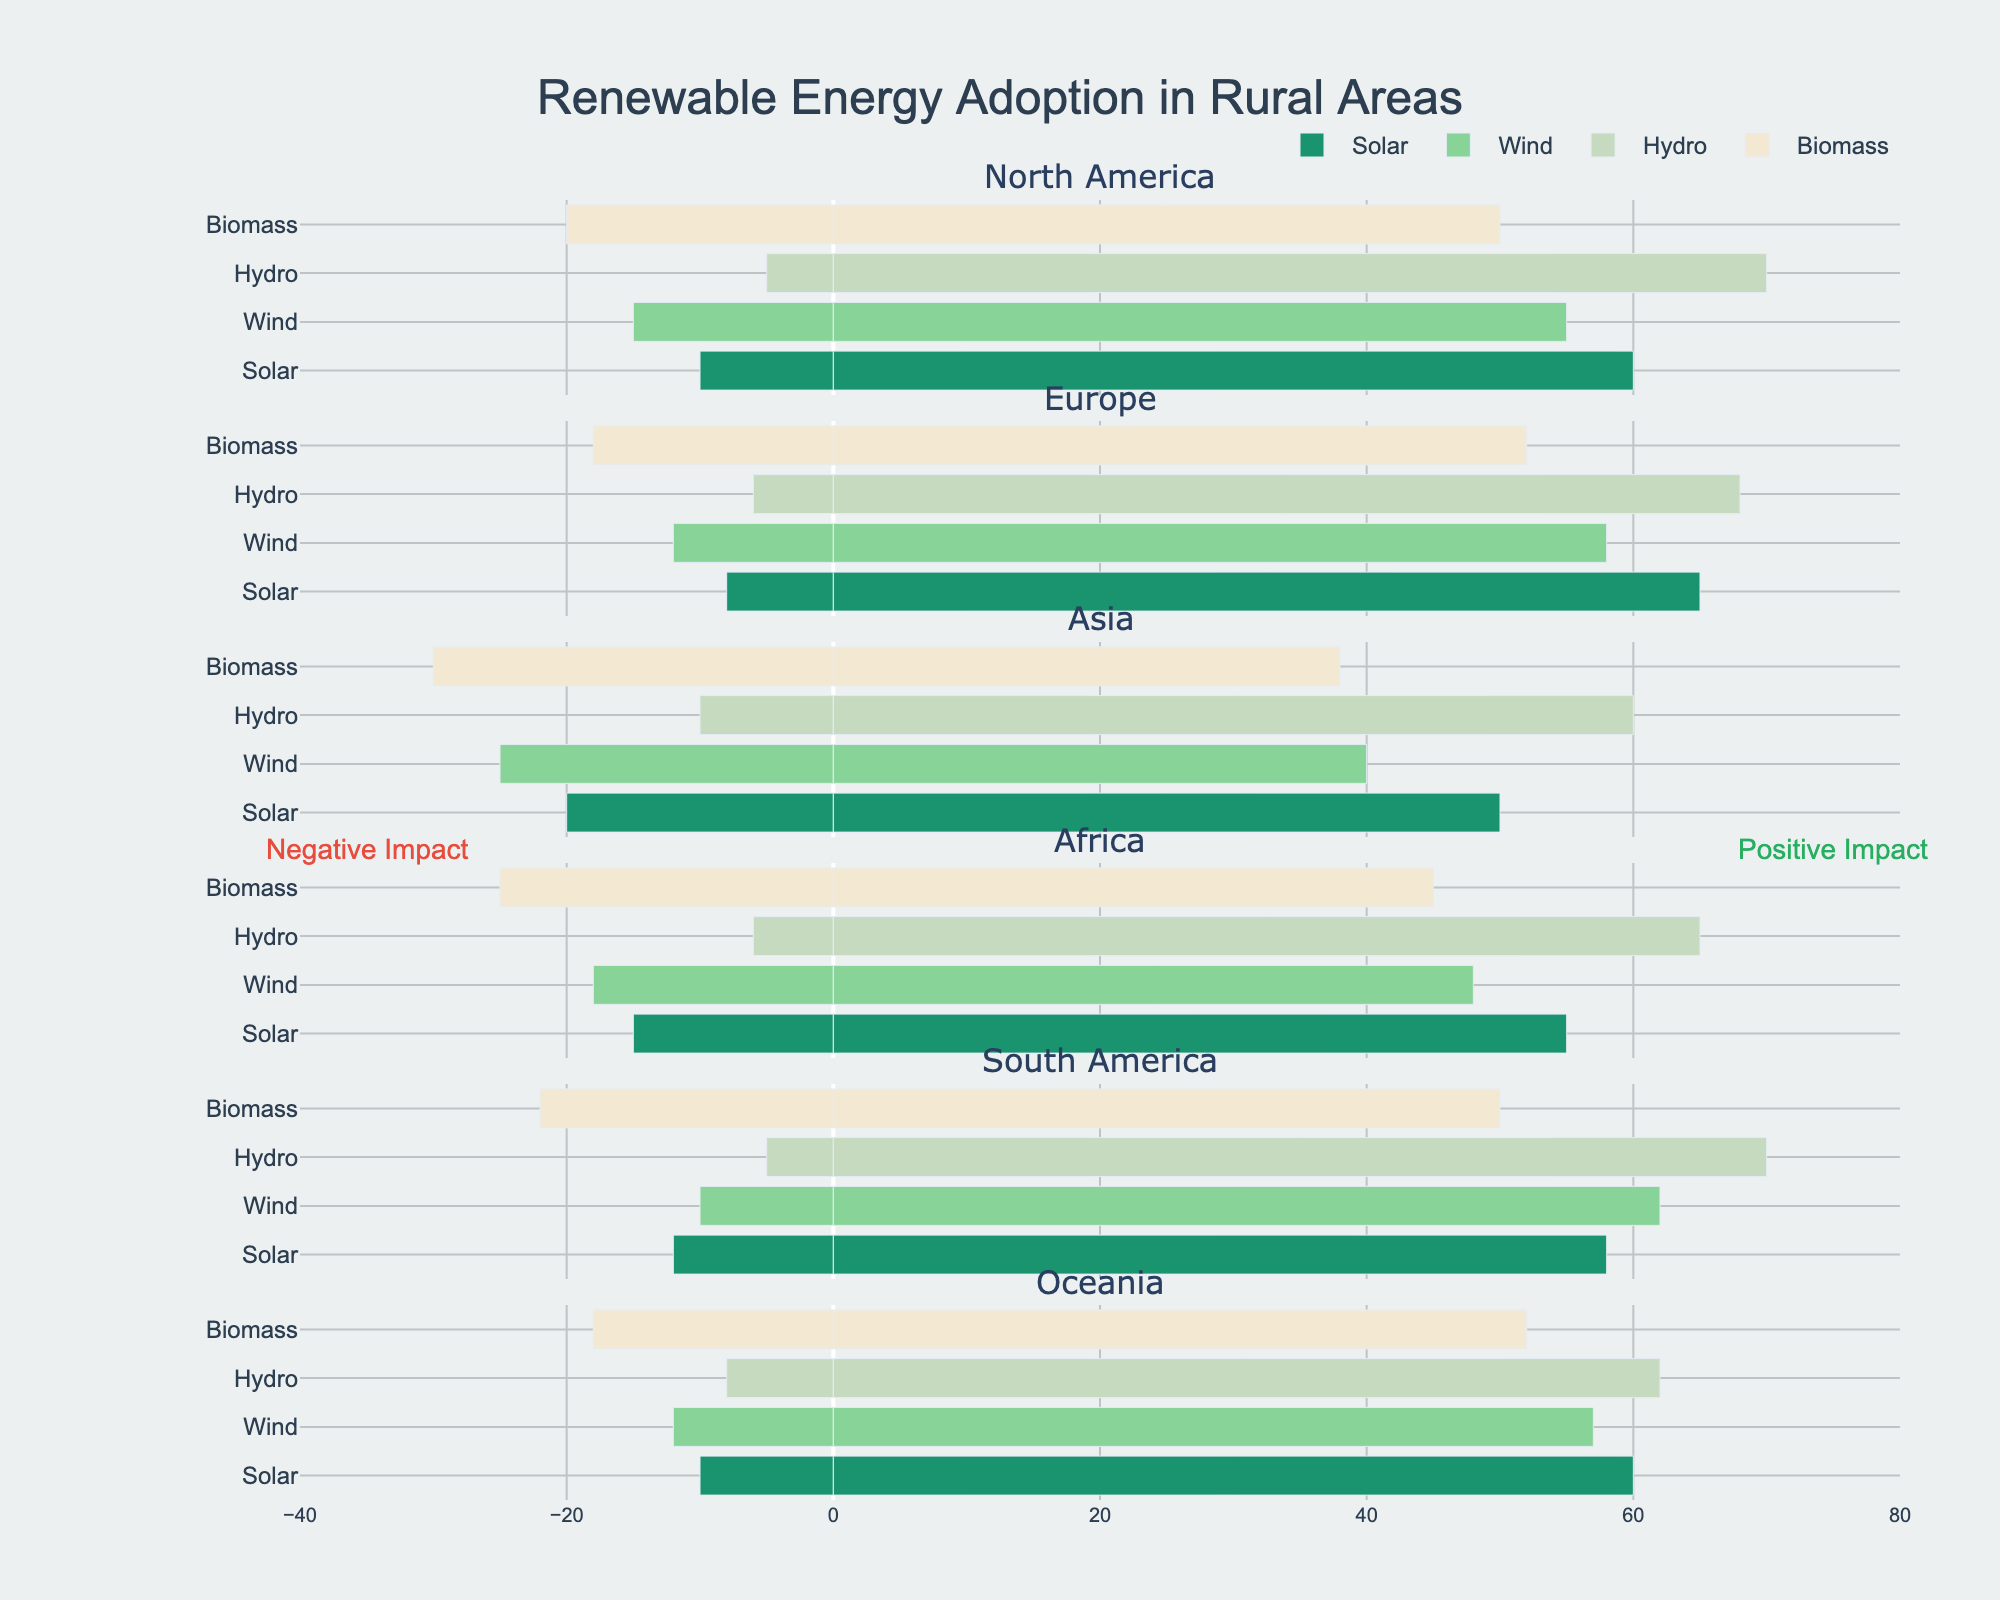What is the total positive impact for Solar energy in North America and Europe combined? To find the total positive impact for Solar energy in North America and Europe combined, add the positive impact values from both regions: 60 (North America) + 65 (Europe) = 125
Answer: 125 Which region has the highest positive impact for Hydro energy? To determine the region with the highest positive impact for Hydro energy, compare the positive impact values for all regions: North America (70), Europe (68), Asia (60), Africa (65), South America (70), and Oceania (62). The highest values are North America and South America, both with 70.
Answer: North America and South America Is the negative impact of Biomass higher in Asia or in Africa? Compare the negative impact values for Biomass in Asia and Africa: 30 (Asia) and 25 (Africa). Since 30 is greater than 25, Biomass has a higher negative impact in Asia.
Answer: Asia Which renewable energy source has the lowest positive impact in Asia? Compare the positive impact values for different renewable energy sources in Asia: Solar (50), Wind (40), Hydro (60), Biomass (38). Biomass has the lowest positive impact with a value of 38.
Answer: Biomass What is the combined negative impact of Wind energy in Africa and Oceania? To find the combined negative impact of Wind energy in Africa and Oceania, sum the negative impact values from both regions: 18 (Africa) + 12 (Oceania) = 30
Answer: 30 Is the positive impact of Solar energy greater than the positive impact of Wind energy in Oceania? Compare the positive impact values for Solar and Wind energy in Oceania: 60 (Solar) and 57 (Wind). Since 60 is greater than 57, the positive impact of Solar energy is greater.
Answer: Yes What is the difference in positive impact between Hydro and Biomass energy in South America? Subtract the positive impact value of Biomass from Hydro in South America: 70 (Hydro) - 50 (Biomass) = 20
Answer: 20 Which energy source has the largest difference between positive and negative impact in Europe? For each energy source in Europe, calculate the difference between positive and negative impact values: Solar (65 - 8 = 57), Wind (58 - 12 = 46), Hydro (68 - 6 = 62), Biomass (52 - 18 = 34). Hydro has the largest difference with a value of 62.
Answer: Hydro Compare the negative impact of Solar energy across the regions. Which regions have a value less than 12? Identify the negative impact of Solar energy in each region: North America (10), Europe (8), Asia (20), Africa (15), South America (12), Oceania (10). Regions with values less than 12 are North America, Europe, and Oceania.
Answer: North America, Europe, Oceania What is the average positive impact of Wind energy across all regions? To find the average positive impact of Wind energy, sum the positive impact values from all regions and divide by the number of regions: (55 + 58 + 40 + 48 + 62 + 57) / 6 = 320 / 6 = 53.33
Answer: 53.33 